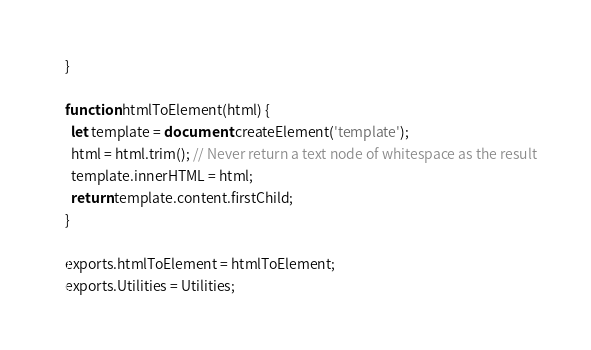Convert code to text. <code><loc_0><loc_0><loc_500><loc_500><_JavaScript_>
}

function htmlToElement(html) {
  let template = document.createElement('template');
  html = html.trim(); // Never return a text node of whitespace as the result
  template.innerHTML = html;
  return template.content.firstChild;
}

exports.htmlToElement = htmlToElement;
exports.Utilities = Utilities;
</code> 